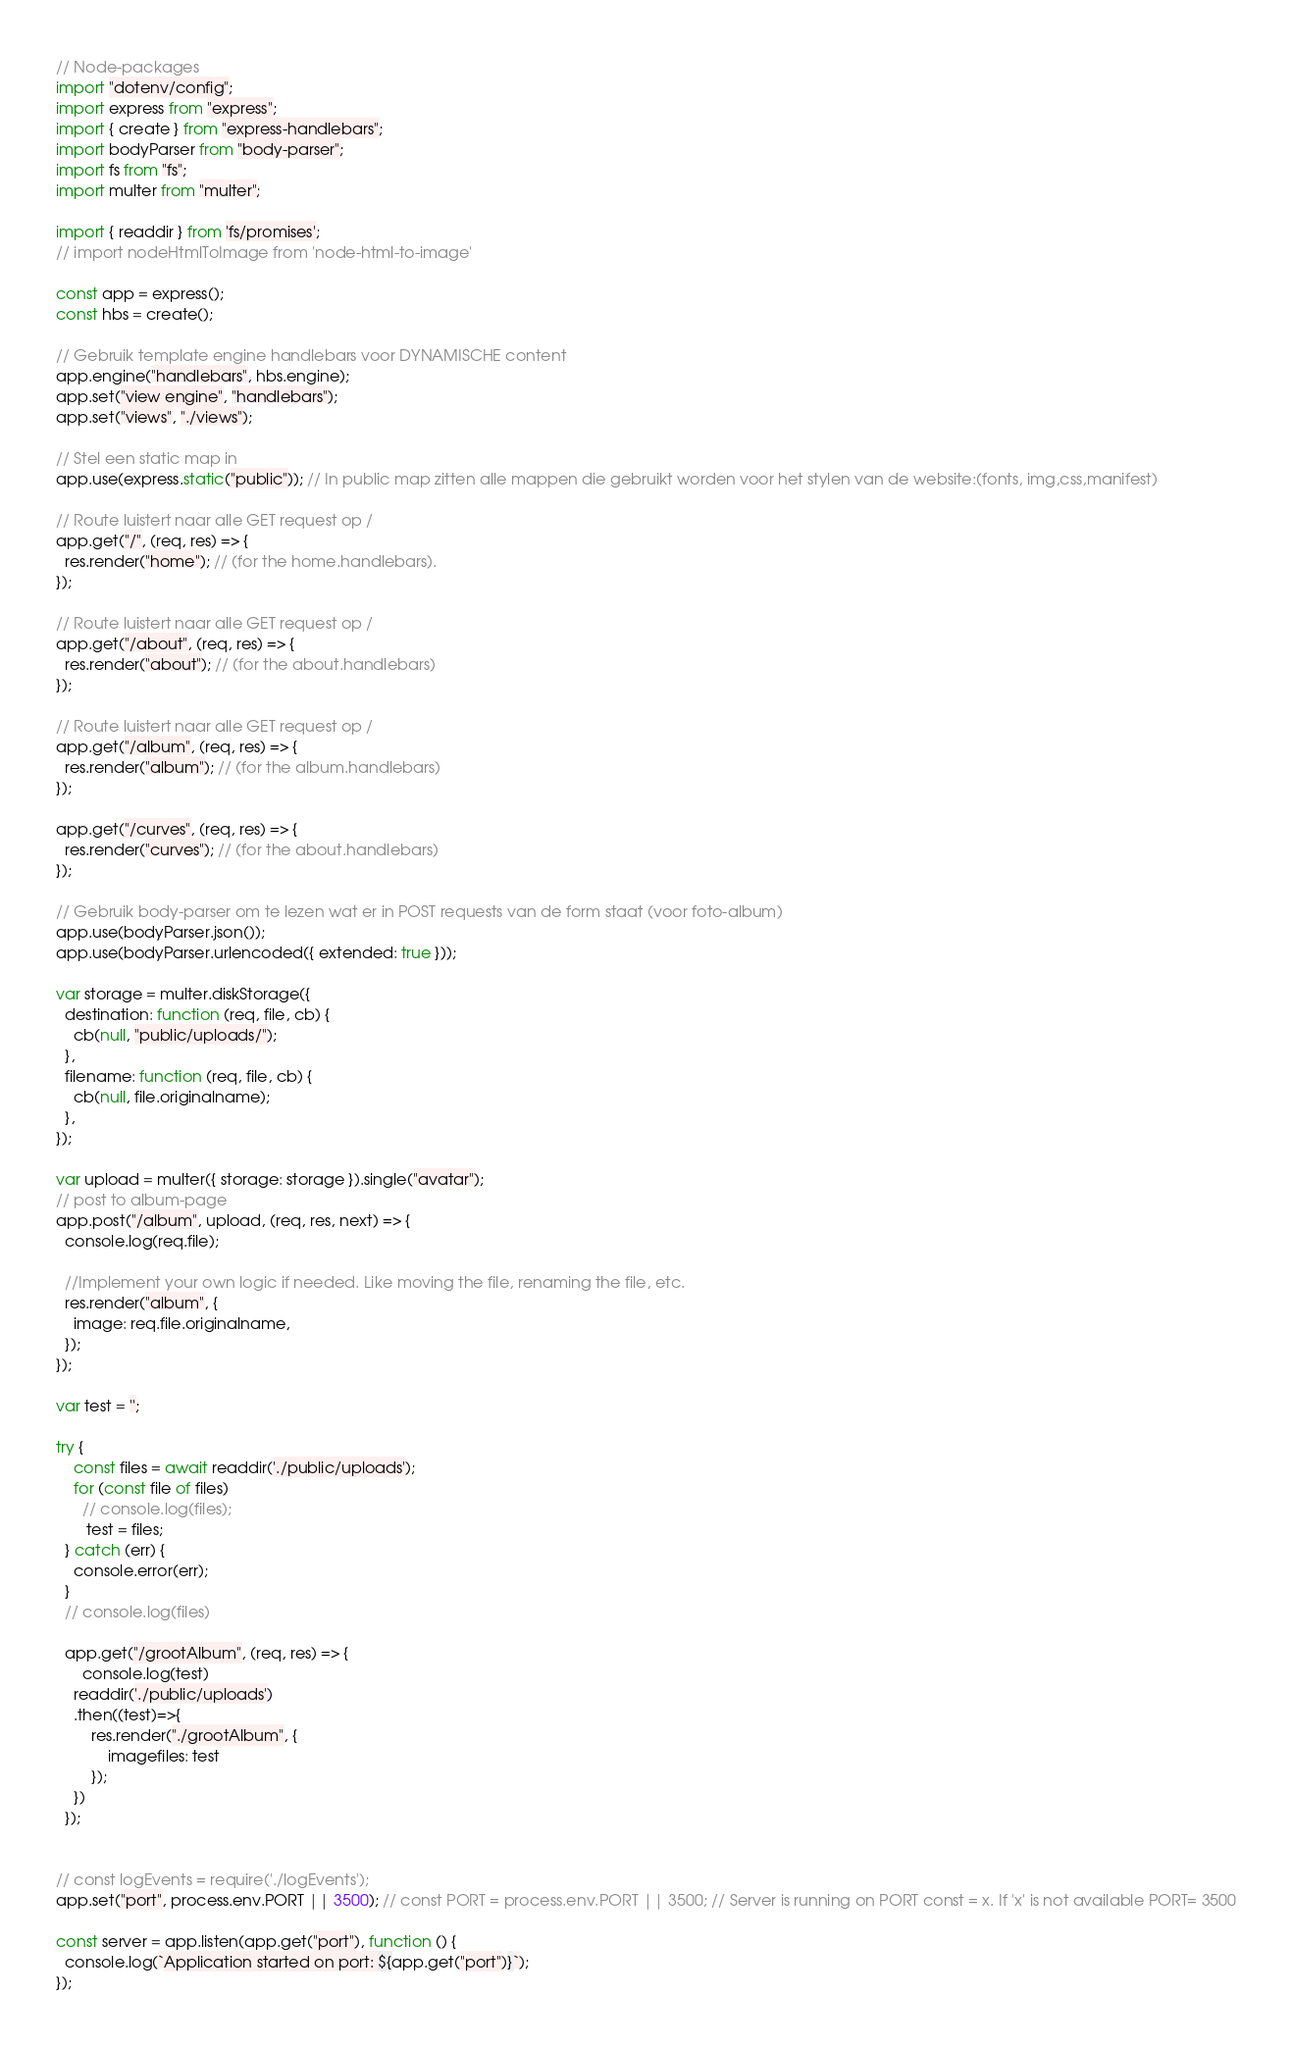<code> <loc_0><loc_0><loc_500><loc_500><_JavaScript_>// Node-packages
import "dotenv/config";
import express from "express";
import { create } from "express-handlebars";
import bodyParser from "body-parser";
import fs from "fs";
import multer from "multer";

import { readdir } from 'fs/promises';
// import nodeHtmlToImage from 'node-html-to-image'

const app = express();
const hbs = create();

// Gebruik template engine handlebars voor DYNAMISCHE content
app.engine("handlebars", hbs.engine);
app.set("view engine", "handlebars");
app.set("views", "./views");

// Stel een static map in
app.use(express.static("public")); // In public map zitten alle mappen die gebruikt worden voor het stylen van de website:(fonts, img,css,manifest)

// Route luistert naar alle GET request op /
app.get("/", (req, res) => {
  res.render("home"); // (for the home.handlebars).
});

// Route luistert naar alle GET request op /
app.get("/about", (req, res) => {
  res.render("about"); // (for the about.handlebars)
});

// Route luistert naar alle GET request op /
app.get("/album", (req, res) => {
  res.render("album"); // (for the album.handlebars)
});

app.get("/curves", (req, res) => {
  res.render("curves"); // (for the about.handlebars)
});

// Gebruik body-parser om te lezen wat er in POST requests van de form staat (voor foto-album)
app.use(bodyParser.json());
app.use(bodyParser.urlencoded({ extended: true }));

var storage = multer.diskStorage({
  destination: function (req, file, cb) {
    cb(null, "public/uploads/");
  },
  filename: function (req, file, cb) {
    cb(null, file.originalname);
  },
});

var upload = multer({ storage: storage }).single("avatar");
// post to album-page 
app.post("/album", upload, (req, res, next) => {
  console.log(req.file);

  //Implement your own logic if needed. Like moving the file, renaming the file, etc.
  res.render("album", {
    image: req.file.originalname,
  });
});

var test = '';

try {
    const files = await readdir('./public/uploads');
    for (const file of files)
      // console.log(files);
       test = files;
  } catch (err) {
    console.error(err);
  }
  // console.log(files)

  app.get("/grootAlbum", (req, res) => {
      console.log(test)
    readdir('./public/uploads')
    .then((test)=>{
        res.render("./grootAlbum", {
            imagefiles: test
        });
    })
  });
 
  
// const logEvents = require('./logEvents');
app.set("port", process.env.PORT || 3500); // const PORT = process.env.PORT || 3500; // Server is running on PORT const = x. If 'x' is not available PORT= 3500

const server = app.listen(app.get("port"), function () {
  console.log(`Application started on port: ${app.get("port")}`);
});</code> 